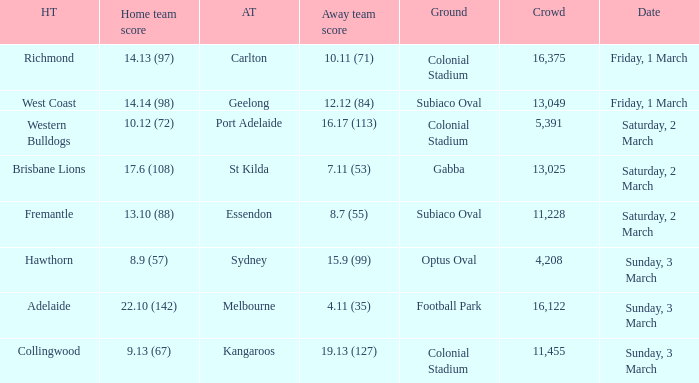Can you give me this table as a dict? {'header': ['HT', 'Home team score', 'AT', 'Away team score', 'Ground', 'Crowd', 'Date'], 'rows': [['Richmond', '14.13 (97)', 'Carlton', '10.11 (71)', 'Colonial Stadium', '16,375', 'Friday, 1 March'], ['West Coast', '14.14 (98)', 'Geelong', '12.12 (84)', 'Subiaco Oval', '13,049', 'Friday, 1 March'], ['Western Bulldogs', '10.12 (72)', 'Port Adelaide', '16.17 (113)', 'Colonial Stadium', '5,391', 'Saturday, 2 March'], ['Brisbane Lions', '17.6 (108)', 'St Kilda', '7.11 (53)', 'Gabba', '13,025', 'Saturday, 2 March'], ['Fremantle', '13.10 (88)', 'Essendon', '8.7 (55)', 'Subiaco Oval', '11,228', 'Saturday, 2 March'], ['Hawthorn', '8.9 (57)', 'Sydney', '15.9 (99)', 'Optus Oval', '4,208', 'Sunday, 3 March'], ['Adelaide', '22.10 (142)', 'Melbourne', '4.11 (35)', 'Football Park', '16,122', 'Sunday, 3 March'], ['Collingwood', '9.13 (67)', 'Kangaroos', '19.13 (127)', 'Colonial Stadium', '11,455', 'Sunday, 3 March']]} What was the basis for the away team sydney? Optus Oval. 